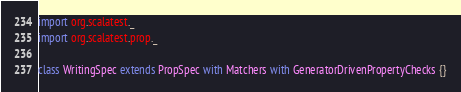<code> <loc_0><loc_0><loc_500><loc_500><_Scala_>import org.scalatest._
import org.scalatest.prop._

class WritingSpec extends PropSpec with Matchers with GeneratorDrivenPropertyChecks {}
</code> 